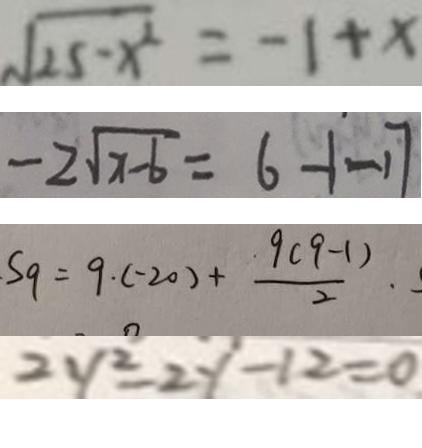Convert formula to latex. <formula><loc_0><loc_0><loc_500><loc_500>\sqrt { 2 5 - x ^ { 2 } } = - 1 + x 
 - 2 \sqrt { x - 6 } = 6 - 1 - 1 7 
 S _ { 9 } = 9 \cdot ( - 2 0 ) + \frac { 9 ( 9 - 1 ) } { 2 } . 
 2 y ^ { 2 } - 2 y - 1 2 = 0</formula> 